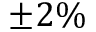Convert formula to latex. <formula><loc_0><loc_0><loc_500><loc_500>\pm 2 \%</formula> 